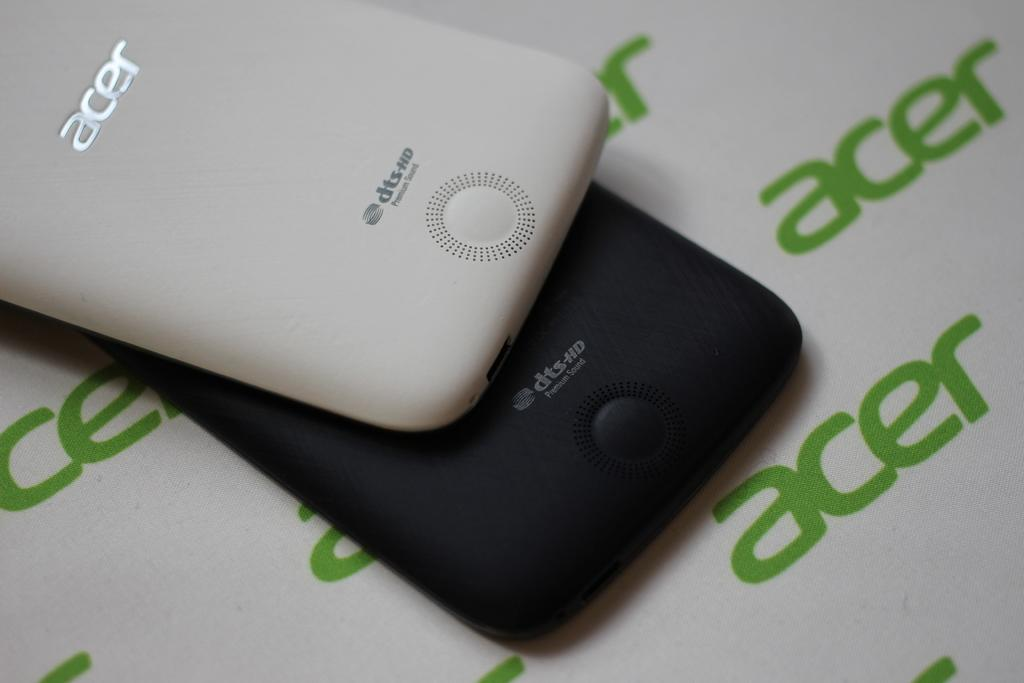<image>
Offer a succinct explanation of the picture presented. An Acer cell phone on top of a phone with the word Acer all over the background. 